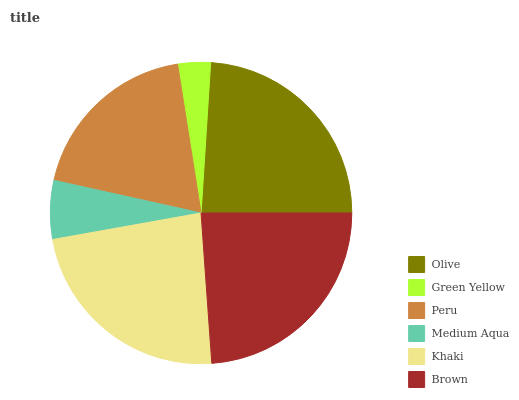Is Green Yellow the minimum?
Answer yes or no. Yes. Is Olive the maximum?
Answer yes or no. Yes. Is Peru the minimum?
Answer yes or no. No. Is Peru the maximum?
Answer yes or no. No. Is Peru greater than Green Yellow?
Answer yes or no. Yes. Is Green Yellow less than Peru?
Answer yes or no. Yes. Is Green Yellow greater than Peru?
Answer yes or no. No. Is Peru less than Green Yellow?
Answer yes or no. No. Is Khaki the high median?
Answer yes or no. Yes. Is Peru the low median?
Answer yes or no. Yes. Is Green Yellow the high median?
Answer yes or no. No. Is Olive the low median?
Answer yes or no. No. 